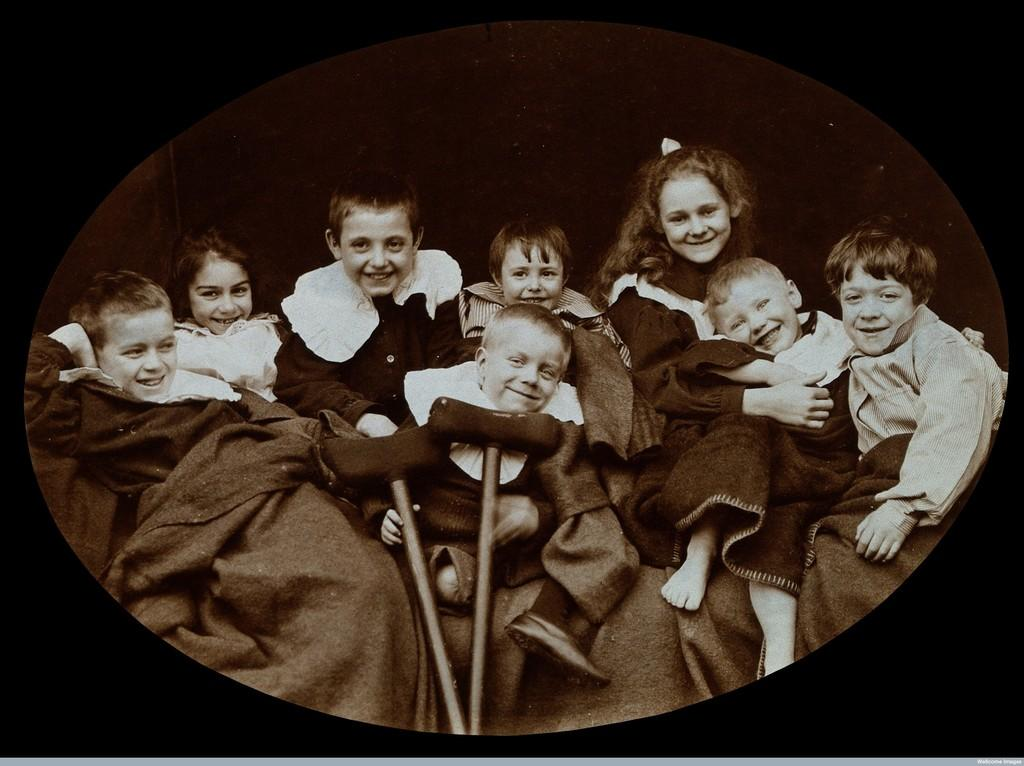What is the main subject of the image? The main subject of the image is a group of children. How are the children feeling in the image? The children are smiling in the image. What are the children sitting on? The children are sitting on an object. What is the color of the background in the image? The background of the image is dark in color. Is there a wheel visible in the image? No, there is no wheel present in the image. What grade are the children in, based on the image? The image does not provide any information about the children's grade level. 